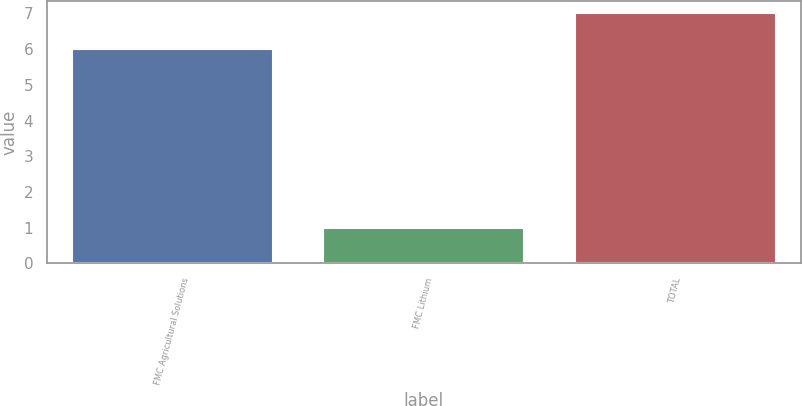<chart> <loc_0><loc_0><loc_500><loc_500><bar_chart><fcel>FMC Agricultural Solutions<fcel>FMC Lithium<fcel>TOTAL<nl><fcel>6<fcel>1<fcel>7<nl></chart> 